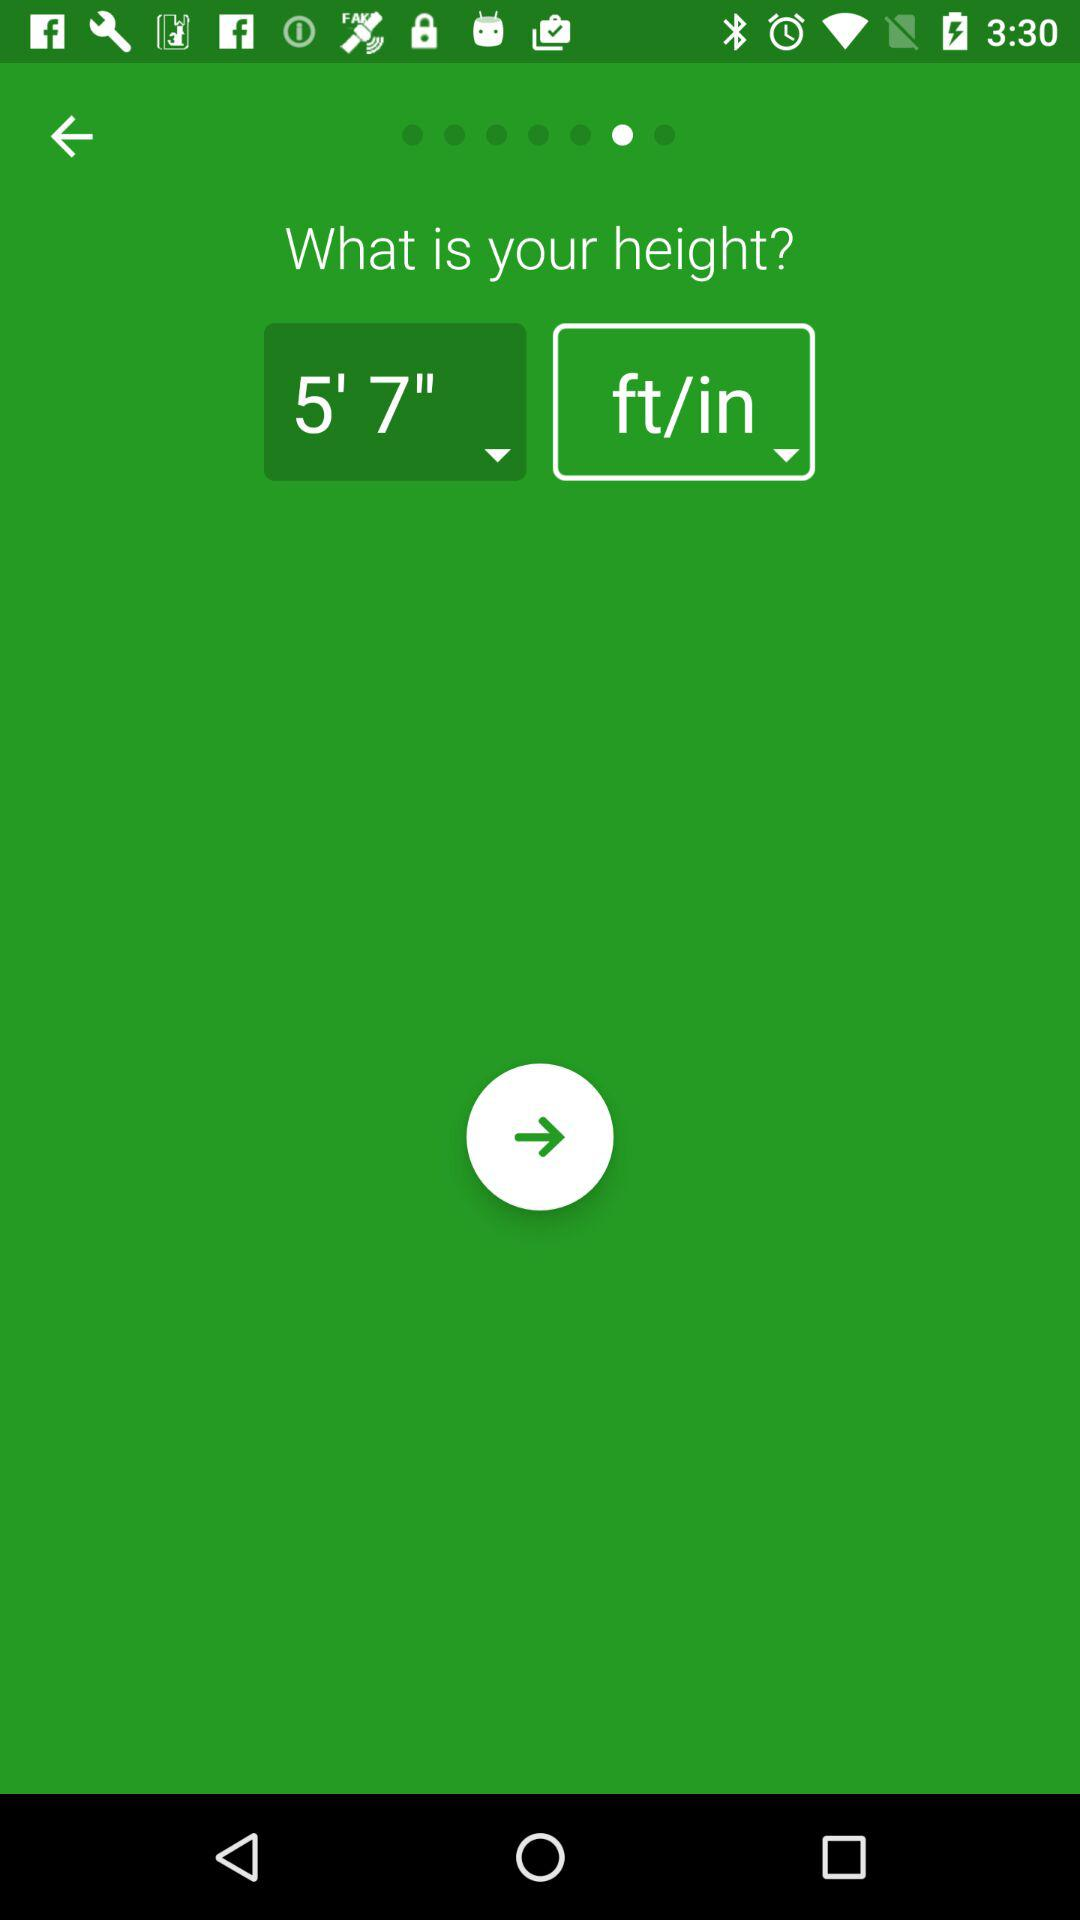What is the height in ft/in? The height is 5 feet and 7 inches. 